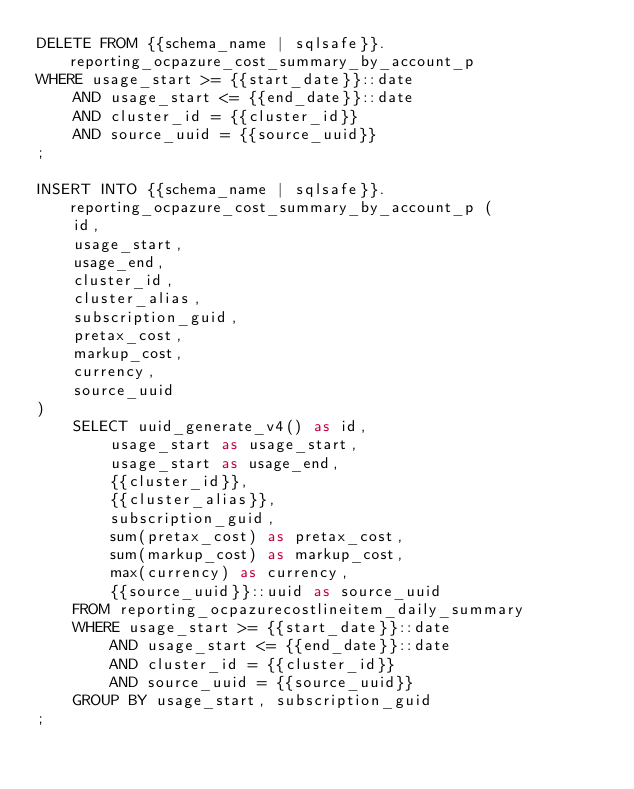<code> <loc_0><loc_0><loc_500><loc_500><_SQL_>DELETE FROM {{schema_name | sqlsafe}}.reporting_ocpazure_cost_summary_by_account_p
WHERE usage_start >= {{start_date}}::date
    AND usage_start <= {{end_date}}::date
    AND cluster_id = {{cluster_id}}
    AND source_uuid = {{source_uuid}}
;

INSERT INTO {{schema_name | sqlsafe}}.reporting_ocpazure_cost_summary_by_account_p (
    id,
    usage_start,
    usage_end,
    cluster_id,
    cluster_alias,
    subscription_guid,
    pretax_cost,
    markup_cost,
    currency,
    source_uuid
)
    SELECT uuid_generate_v4() as id,
        usage_start as usage_start,
        usage_start as usage_end,
        {{cluster_id}},
        {{cluster_alias}},
        subscription_guid,
        sum(pretax_cost) as pretax_cost,
        sum(markup_cost) as markup_cost,
        max(currency) as currency,
        {{source_uuid}}::uuid as source_uuid
    FROM reporting_ocpazurecostlineitem_daily_summary
    WHERE usage_start >= {{start_date}}::date
        AND usage_start <= {{end_date}}::date
        AND cluster_id = {{cluster_id}}
        AND source_uuid = {{source_uuid}}
    GROUP BY usage_start, subscription_guid
;
</code> 